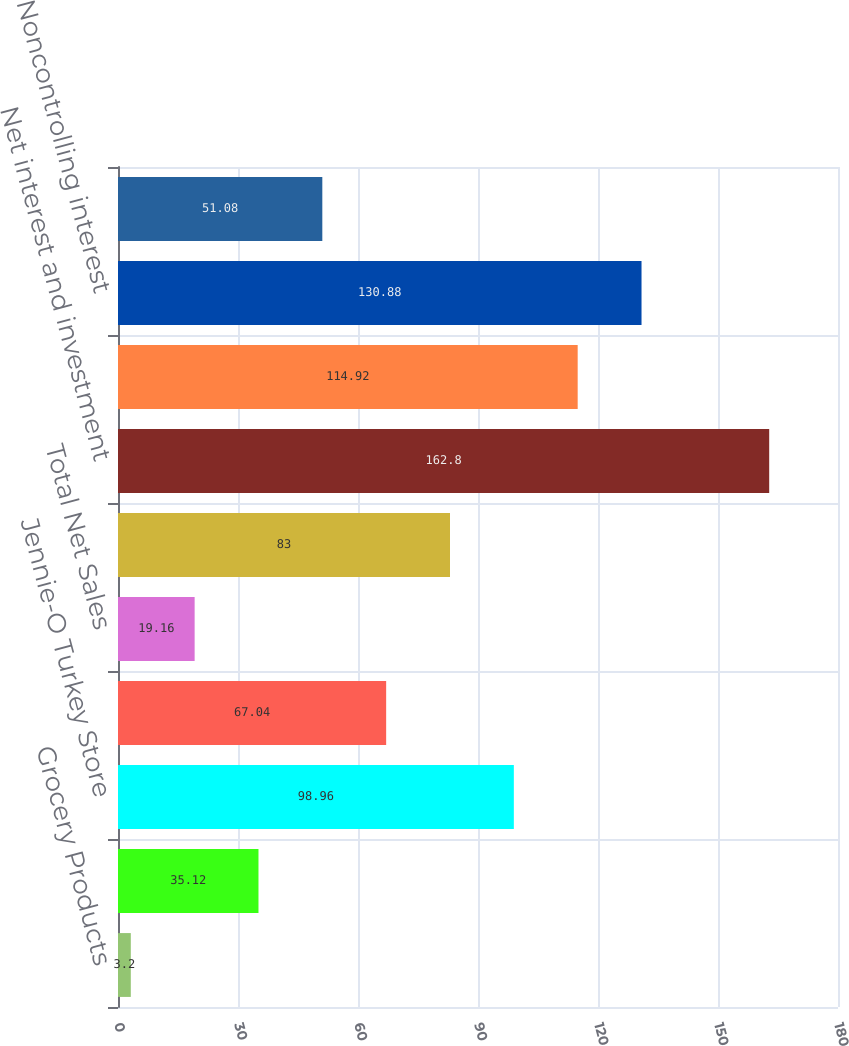Convert chart to OTSL. <chart><loc_0><loc_0><loc_500><loc_500><bar_chart><fcel>Grocery Products<fcel>Refrigerated Foods<fcel>Jennie-O Turkey Store<fcel>International & Other<fcel>Total Net Sales<fcel>Total Segment Operating Profit<fcel>Net interest and investment<fcel>General corporate expense<fcel>Noncontrolling interest<fcel>Earnings Before Income Taxes<nl><fcel>3.2<fcel>35.12<fcel>98.96<fcel>67.04<fcel>19.16<fcel>83<fcel>162.8<fcel>114.92<fcel>130.88<fcel>51.08<nl></chart> 